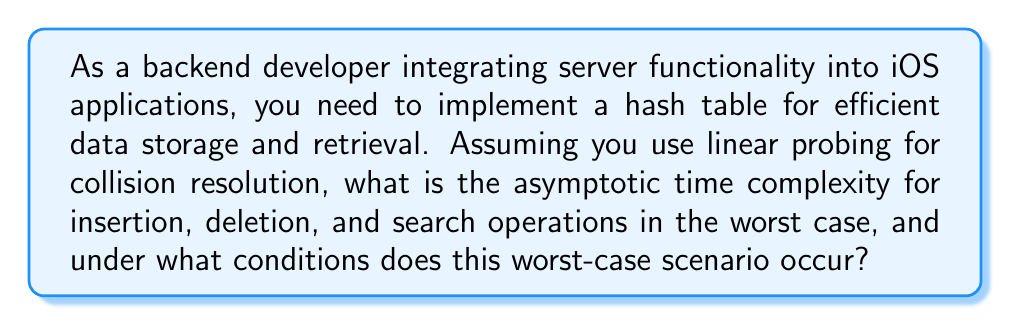Can you answer this question? To understand the asymptotic complexity of a hash table with linear probing, we need to consider the following:

1. Hash Function: Assume we have a good hash function that distributes keys uniformly across the table.

2. Load Factor: Define $\alpha$ as the load factor, where $\alpha = \frac{n}{m}$, $n$ is the number of elements, and $m$ is the table size.

3. Linear Probing: When a collision occurs, we check the next slot sequentially until an empty slot is found.

For insertion, deletion, and search operations:

1. Best Case: $O(1)$ when there are no collisions.

2. Average Case: $O(1)$ when the load factor $\alpha$ is kept low (typically $\alpha < 0.7$).

3. Worst Case: $O(n)$ when all keys hash to the same slot, creating a single long chain.

The worst-case scenario occurs when:

a) The hash function produces many collisions, causing keys to cluster.
b) The table becomes nearly full ($\alpha \approx 1$).

In this case, for each operation:

- Insertion: We may need to probe through almost all elements to find an empty slot.
- Deletion: We need to search for the element (potentially probing all slots) and then handle the deletion carefully to maintain the integrity of the probe sequence.
- Search: We may need to probe through all elements if the key is not present or is the last in a long chain.

The probability of this worst-case scenario increases as $\alpha$ approaches 1, which is why it's crucial to resize the hash table when the load factor exceeds a certain threshold (typically around 0.7).

To mitigate this, you should:

1. Choose a good hash function that minimizes collisions.
2. Implement dynamic resizing to keep $\alpha$ low.
3. Consider alternative collision resolution techniques like double hashing or separate chaining for better performance in high-load scenarios.
Answer: The asymptotic time complexity for insertion, deletion, and search operations in a hash table with linear probing is $O(n)$ in the worst case, where $n$ is the number of elements in the table. This worst-case scenario occurs when all keys hash to the same slot, creating a single long chain, typically when the hash function produces many collisions and the table becomes nearly full ($\alpha \approx 1$). 